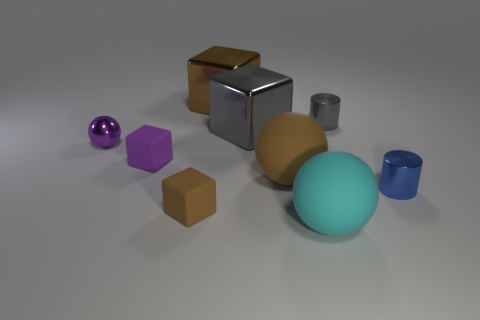Add 1 large blue metallic balls. How many objects exist? 10 Subtract all cubes. How many objects are left? 5 Subtract all tiny purple spheres. Subtract all small brown things. How many objects are left? 7 Add 4 metallic cylinders. How many metallic cylinders are left? 6 Add 5 cylinders. How many cylinders exist? 7 Subtract 0 blue cubes. How many objects are left? 9 